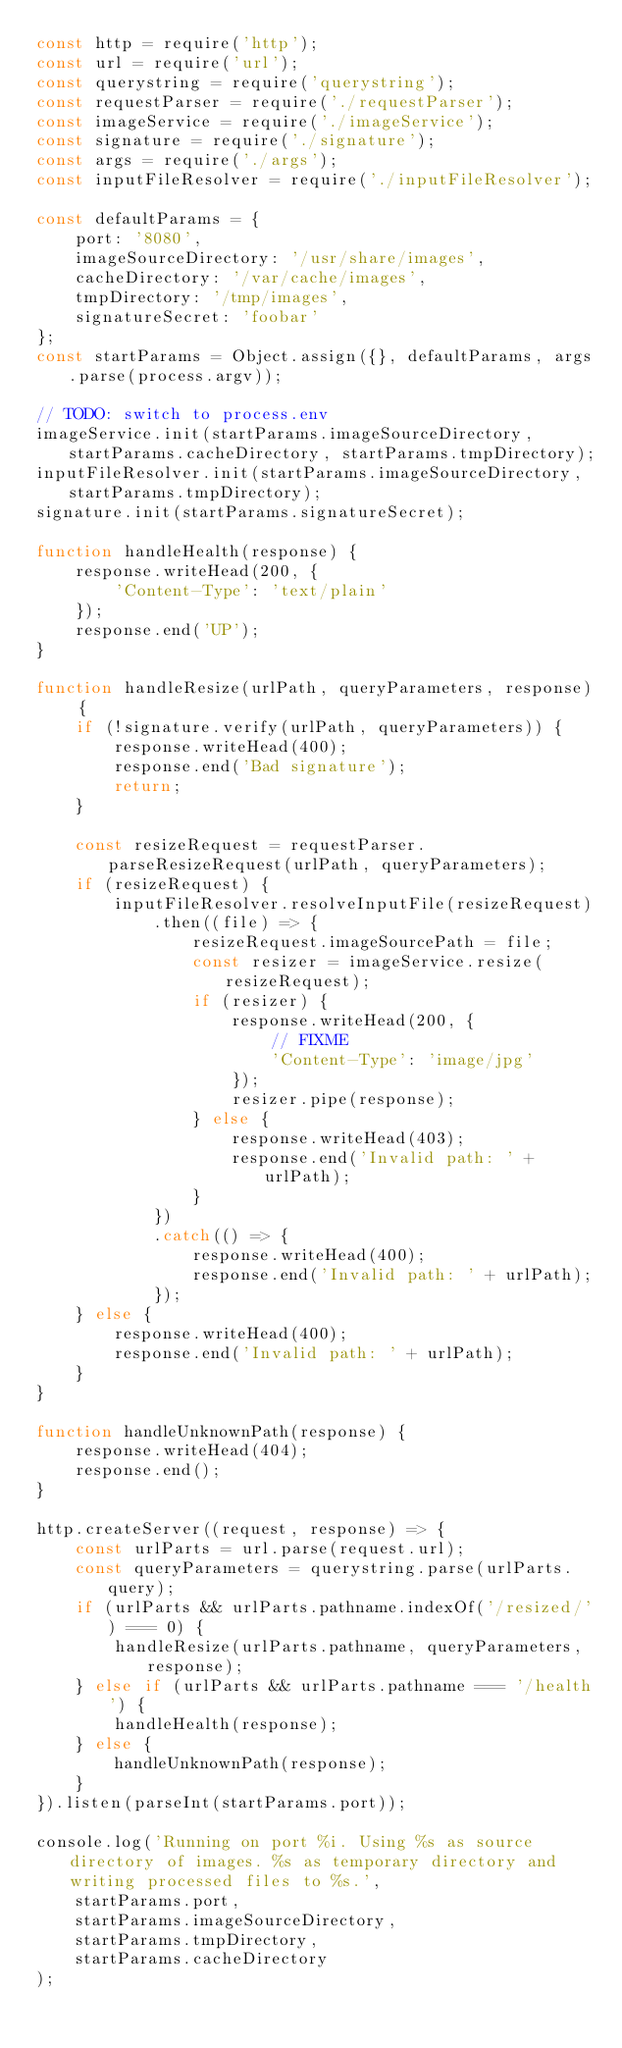Convert code to text. <code><loc_0><loc_0><loc_500><loc_500><_JavaScript_>const http = require('http');
const url = require('url');
const querystring = require('querystring');
const requestParser = require('./requestParser');
const imageService = require('./imageService');
const signature = require('./signature');
const args = require('./args');
const inputFileResolver = require('./inputFileResolver');

const defaultParams = {
    port: '8080',
    imageSourceDirectory: '/usr/share/images',
    cacheDirectory: '/var/cache/images',
    tmpDirectory: '/tmp/images',
    signatureSecret: 'foobar'
};
const startParams = Object.assign({}, defaultParams, args.parse(process.argv));

// TODO: switch to process.env
imageService.init(startParams.imageSourceDirectory, startParams.cacheDirectory, startParams.tmpDirectory);
inputFileResolver.init(startParams.imageSourceDirectory, startParams.tmpDirectory);
signature.init(startParams.signatureSecret);

function handleHealth(response) {
    response.writeHead(200, {
        'Content-Type': 'text/plain'
    });
    response.end('UP');
}

function handleResize(urlPath, queryParameters, response) {
    if (!signature.verify(urlPath, queryParameters)) {
        response.writeHead(400);
        response.end('Bad signature');
        return;        
    }

    const resizeRequest = requestParser.parseResizeRequest(urlPath, queryParameters);
    if (resizeRequest) {
        inputFileResolver.resolveInputFile(resizeRequest)
            .then((file) => {
                resizeRequest.imageSourcePath = file;
                const resizer = imageService.resize(resizeRequest);
                if (resizer) {
                    response.writeHead(200, {
                        // FIXME
                        'Content-Type': 'image/jpg'
                    });
                    resizer.pipe(response);
                } else {
                    response.writeHead(403);
                    response.end('Invalid path: ' + urlPath);
                }
            })
            .catch(() => {
                response.writeHead(400);
                response.end('Invalid path: ' + urlPath);
            });
    } else {
        response.writeHead(400);
        response.end('Invalid path: ' + urlPath);
    }
}

function handleUnknownPath(response) {
    response.writeHead(404);
    response.end();
}

http.createServer((request, response) => {
    const urlParts = url.parse(request.url);
    const queryParameters = querystring.parse(urlParts.query);
    if (urlParts && urlParts.pathname.indexOf('/resized/') === 0) {
        handleResize(urlParts.pathname, queryParameters, response);
    } else if (urlParts && urlParts.pathname === '/health') {
        handleHealth(response);
    } else {
        handleUnknownPath(response);
    }
}).listen(parseInt(startParams.port));

console.log('Running on port %i. Using %s as source directory of images. %s as temporary directory and writing processed files to %s.',
    startParams.port,
    startParams.imageSourceDirectory,
    startParams.tmpDirectory,
    startParams.cacheDirectory
);</code> 